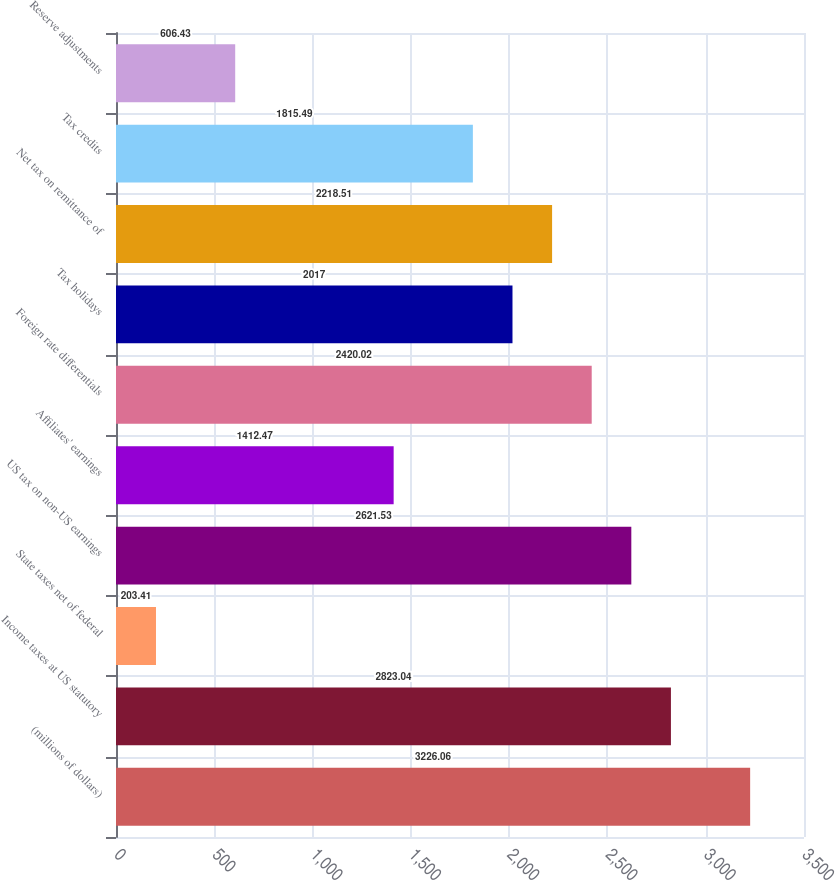Convert chart. <chart><loc_0><loc_0><loc_500><loc_500><bar_chart><fcel>(millions of dollars)<fcel>Income taxes at US statutory<fcel>State taxes net of federal<fcel>US tax on non-US earnings<fcel>Affiliates' earnings<fcel>Foreign rate differentials<fcel>Tax holidays<fcel>Net tax on remittance of<fcel>Tax credits<fcel>Reserve adjustments<nl><fcel>3226.06<fcel>2823.04<fcel>203.41<fcel>2621.53<fcel>1412.47<fcel>2420.02<fcel>2017<fcel>2218.51<fcel>1815.49<fcel>606.43<nl></chart> 